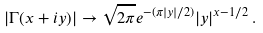Convert formula to latex. <formula><loc_0><loc_0><loc_500><loc_500>| \Gamma ( x + i y ) | \to \sqrt { 2 \pi } e ^ { - ( \pi | y | / 2 ) } | y | ^ { x - 1 / 2 } \, .</formula> 